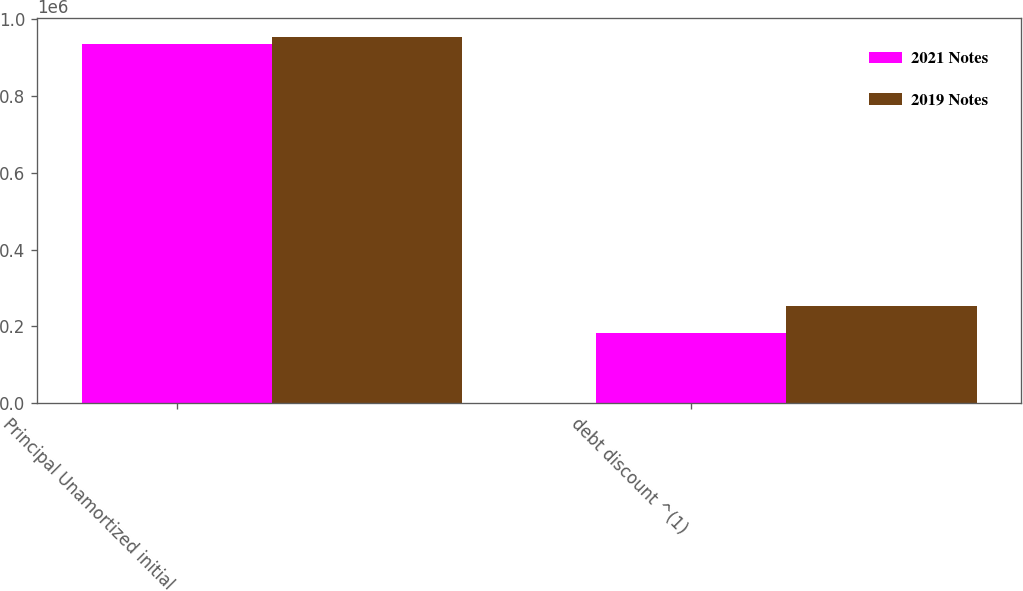Convert chart. <chart><loc_0><loc_0><loc_500><loc_500><stacked_bar_chart><ecel><fcel>Principal Unamortized initial<fcel>debt discount ^(1)<nl><fcel>2021 Notes<fcel>935000<fcel>181994<nl><fcel>2019 Notes<fcel>954000<fcel>251911<nl></chart> 